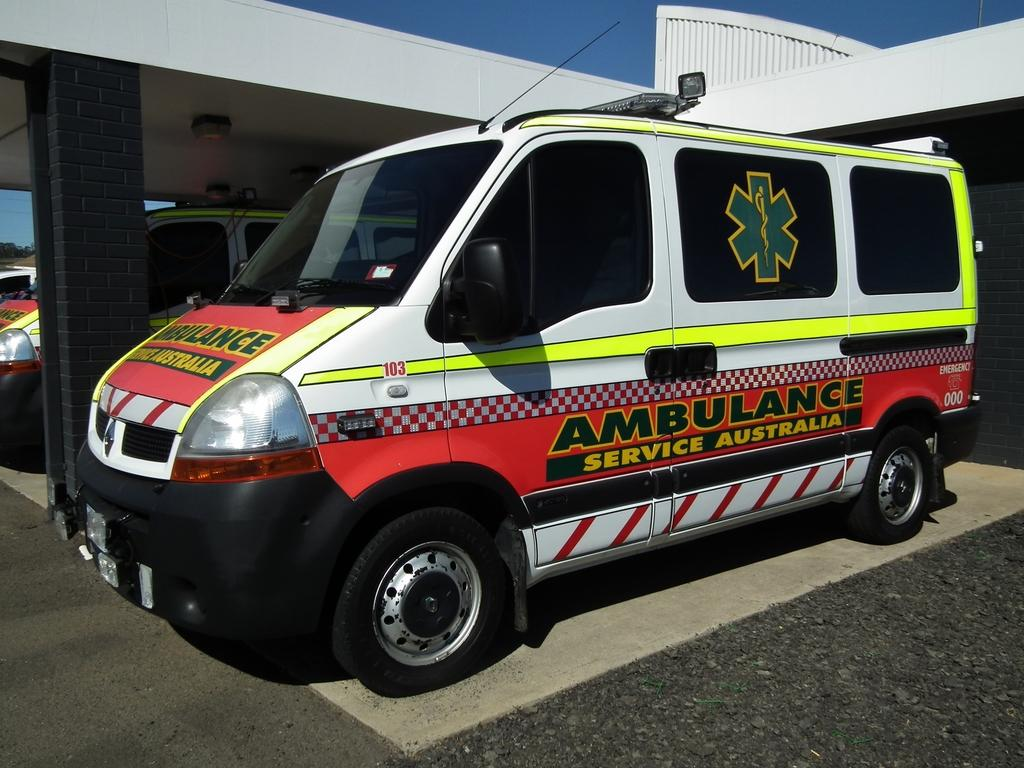<image>
Share a concise interpretation of the image provided. A ambulance from Australia is parked in front of a building. 